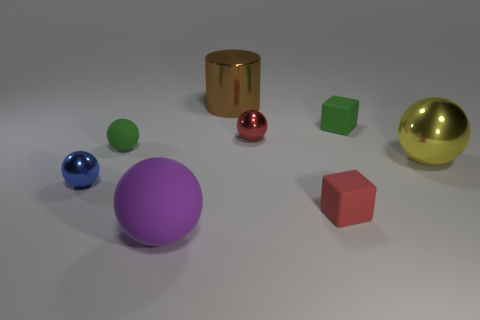Subtract all red shiny balls. How many balls are left? 4 Subtract all purple spheres. How many spheres are left? 4 Subtract 1 balls. How many balls are left? 4 Add 1 red cubes. How many objects exist? 9 Subtract all green spheres. Subtract all green cubes. How many spheres are left? 4 Subtract all big shiny balls. Subtract all small red blocks. How many objects are left? 6 Add 5 small objects. How many small objects are left? 10 Add 5 blue spheres. How many blue spheres exist? 6 Subtract 1 yellow balls. How many objects are left? 7 Subtract all blocks. How many objects are left? 6 